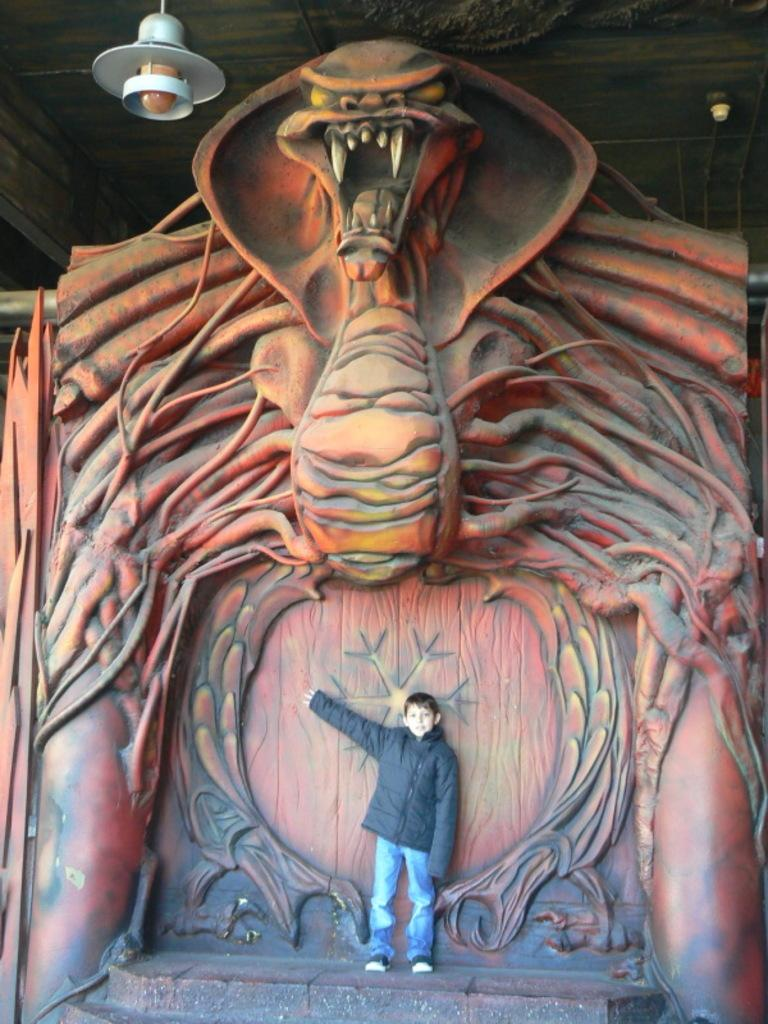What is the main subject of the image? There is a child standing in the image. Where is the child standing? The child is standing on the floor. What can be seen in the background of the image? There is a sculpture and an electric light hanging from the roof in the background of the image. What type of veil is the child wearing in the image? There is no veil present in the image; the child is not wearing any clothing or accessories that resemble a veil. 